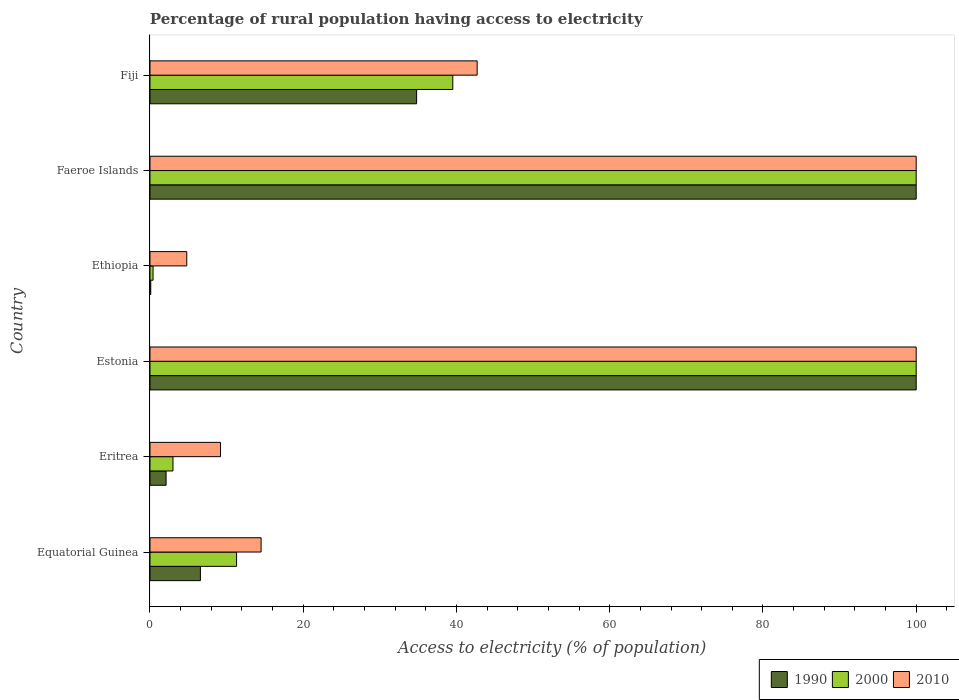How many groups of bars are there?
Make the answer very short. 6. Are the number of bars per tick equal to the number of legend labels?
Keep it short and to the point. Yes. How many bars are there on the 3rd tick from the bottom?
Your response must be concise. 3. What is the label of the 5th group of bars from the top?
Keep it short and to the point. Eritrea. In how many cases, is the number of bars for a given country not equal to the number of legend labels?
Your answer should be compact. 0. Across all countries, what is the maximum percentage of rural population having access to electricity in 2010?
Your answer should be compact. 100. Across all countries, what is the minimum percentage of rural population having access to electricity in 2000?
Provide a succinct answer. 0.4. In which country was the percentage of rural population having access to electricity in 2000 maximum?
Make the answer very short. Estonia. In which country was the percentage of rural population having access to electricity in 2000 minimum?
Offer a very short reply. Ethiopia. What is the total percentage of rural population having access to electricity in 1990 in the graph?
Offer a very short reply. 243.58. What is the difference between the percentage of rural population having access to electricity in 1990 in Faeroe Islands and the percentage of rural population having access to electricity in 2010 in Eritrea?
Your response must be concise. 90.8. What is the average percentage of rural population having access to electricity in 2000 per country?
Provide a succinct answer. 42.37. What is the difference between the percentage of rural population having access to electricity in 2000 and percentage of rural population having access to electricity in 2010 in Faeroe Islands?
Provide a short and direct response. 0. What is the ratio of the percentage of rural population having access to electricity in 2000 in Faeroe Islands to that in Fiji?
Offer a very short reply. 2.53. Is the percentage of rural population having access to electricity in 1990 in Equatorial Guinea less than that in Faeroe Islands?
Give a very brief answer. Yes. Is the difference between the percentage of rural population having access to electricity in 2000 in Ethiopia and Fiji greater than the difference between the percentage of rural population having access to electricity in 2010 in Ethiopia and Fiji?
Provide a succinct answer. No. What is the difference between the highest and the second highest percentage of rural population having access to electricity in 1990?
Ensure brevity in your answer.  0. What is the difference between the highest and the lowest percentage of rural population having access to electricity in 2010?
Offer a terse response. 95.2. Is the sum of the percentage of rural population having access to electricity in 2000 in Eritrea and Ethiopia greater than the maximum percentage of rural population having access to electricity in 2010 across all countries?
Offer a terse response. No. What does the 1st bar from the top in Faeroe Islands represents?
Your answer should be compact. 2010. What does the 3rd bar from the bottom in Fiji represents?
Give a very brief answer. 2010. Is it the case that in every country, the sum of the percentage of rural population having access to electricity in 2000 and percentage of rural population having access to electricity in 1990 is greater than the percentage of rural population having access to electricity in 2010?
Give a very brief answer. No. How many bars are there?
Offer a terse response. 18. Are all the bars in the graph horizontal?
Your answer should be compact. Yes. Does the graph contain any zero values?
Your answer should be compact. No. Does the graph contain grids?
Ensure brevity in your answer.  No. Where does the legend appear in the graph?
Make the answer very short. Bottom right. How are the legend labels stacked?
Provide a succinct answer. Horizontal. What is the title of the graph?
Offer a terse response. Percentage of rural population having access to electricity. What is the label or title of the X-axis?
Offer a terse response. Access to electricity (% of population). What is the label or title of the Y-axis?
Offer a very short reply. Country. What is the Access to electricity (% of population) in 1990 in Equatorial Guinea?
Keep it short and to the point. 6.58. What is the Access to electricity (% of population) of 2000 in Equatorial Guinea?
Give a very brief answer. 11.3. What is the Access to electricity (% of population) of 2010 in Equatorial Guinea?
Offer a very short reply. 14.5. What is the Access to electricity (% of population) in 2000 in Eritrea?
Your response must be concise. 3. What is the Access to electricity (% of population) in 1990 in Estonia?
Provide a succinct answer. 100. What is the Access to electricity (% of population) of 2010 in Estonia?
Your answer should be compact. 100. What is the Access to electricity (% of population) of 1990 in Ethiopia?
Ensure brevity in your answer.  0.1. What is the Access to electricity (% of population) in 2010 in Ethiopia?
Provide a short and direct response. 4.8. What is the Access to electricity (% of population) in 2000 in Faeroe Islands?
Your answer should be compact. 100. What is the Access to electricity (% of population) in 2010 in Faeroe Islands?
Keep it short and to the point. 100. What is the Access to electricity (% of population) of 1990 in Fiji?
Your answer should be very brief. 34.8. What is the Access to electricity (% of population) in 2000 in Fiji?
Give a very brief answer. 39.52. What is the Access to electricity (% of population) of 2010 in Fiji?
Keep it short and to the point. 42.7. Across all countries, what is the maximum Access to electricity (% of population) in 1990?
Give a very brief answer. 100. Across all countries, what is the maximum Access to electricity (% of population) in 2000?
Keep it short and to the point. 100. Across all countries, what is the maximum Access to electricity (% of population) in 2010?
Offer a terse response. 100. What is the total Access to electricity (% of population) in 1990 in the graph?
Give a very brief answer. 243.58. What is the total Access to electricity (% of population) of 2000 in the graph?
Provide a succinct answer. 254.22. What is the total Access to electricity (% of population) in 2010 in the graph?
Give a very brief answer. 271.2. What is the difference between the Access to electricity (% of population) in 1990 in Equatorial Guinea and that in Eritrea?
Provide a short and direct response. 4.48. What is the difference between the Access to electricity (% of population) in 2000 in Equatorial Guinea and that in Eritrea?
Your answer should be compact. 8.3. What is the difference between the Access to electricity (% of population) of 1990 in Equatorial Guinea and that in Estonia?
Offer a very short reply. -93.42. What is the difference between the Access to electricity (% of population) in 2000 in Equatorial Guinea and that in Estonia?
Provide a succinct answer. -88.7. What is the difference between the Access to electricity (% of population) of 2010 in Equatorial Guinea and that in Estonia?
Make the answer very short. -85.5. What is the difference between the Access to electricity (% of population) in 1990 in Equatorial Guinea and that in Ethiopia?
Keep it short and to the point. 6.48. What is the difference between the Access to electricity (% of population) of 2000 in Equatorial Guinea and that in Ethiopia?
Ensure brevity in your answer.  10.9. What is the difference between the Access to electricity (% of population) of 1990 in Equatorial Guinea and that in Faeroe Islands?
Offer a very short reply. -93.42. What is the difference between the Access to electricity (% of population) of 2000 in Equatorial Guinea and that in Faeroe Islands?
Your response must be concise. -88.7. What is the difference between the Access to electricity (% of population) of 2010 in Equatorial Guinea and that in Faeroe Islands?
Your answer should be compact. -85.5. What is the difference between the Access to electricity (% of population) in 1990 in Equatorial Guinea and that in Fiji?
Ensure brevity in your answer.  -28.22. What is the difference between the Access to electricity (% of population) in 2000 in Equatorial Guinea and that in Fiji?
Ensure brevity in your answer.  -28.22. What is the difference between the Access to electricity (% of population) of 2010 in Equatorial Guinea and that in Fiji?
Ensure brevity in your answer.  -28.2. What is the difference between the Access to electricity (% of population) of 1990 in Eritrea and that in Estonia?
Offer a very short reply. -97.9. What is the difference between the Access to electricity (% of population) of 2000 in Eritrea and that in Estonia?
Ensure brevity in your answer.  -97. What is the difference between the Access to electricity (% of population) of 2010 in Eritrea and that in Estonia?
Your answer should be compact. -90.8. What is the difference between the Access to electricity (% of population) of 2000 in Eritrea and that in Ethiopia?
Offer a very short reply. 2.6. What is the difference between the Access to electricity (% of population) of 1990 in Eritrea and that in Faeroe Islands?
Keep it short and to the point. -97.9. What is the difference between the Access to electricity (% of population) in 2000 in Eritrea and that in Faeroe Islands?
Provide a short and direct response. -97. What is the difference between the Access to electricity (% of population) of 2010 in Eritrea and that in Faeroe Islands?
Your response must be concise. -90.8. What is the difference between the Access to electricity (% of population) of 1990 in Eritrea and that in Fiji?
Offer a terse response. -32.7. What is the difference between the Access to electricity (% of population) in 2000 in Eritrea and that in Fiji?
Your response must be concise. -36.52. What is the difference between the Access to electricity (% of population) in 2010 in Eritrea and that in Fiji?
Ensure brevity in your answer.  -33.5. What is the difference between the Access to electricity (% of population) of 1990 in Estonia and that in Ethiopia?
Make the answer very short. 99.9. What is the difference between the Access to electricity (% of population) in 2000 in Estonia and that in Ethiopia?
Your answer should be compact. 99.6. What is the difference between the Access to electricity (% of population) of 2010 in Estonia and that in Ethiopia?
Your response must be concise. 95.2. What is the difference between the Access to electricity (% of population) in 2000 in Estonia and that in Faeroe Islands?
Provide a short and direct response. 0. What is the difference between the Access to electricity (% of population) of 2010 in Estonia and that in Faeroe Islands?
Keep it short and to the point. 0. What is the difference between the Access to electricity (% of population) in 1990 in Estonia and that in Fiji?
Ensure brevity in your answer.  65.2. What is the difference between the Access to electricity (% of population) in 2000 in Estonia and that in Fiji?
Your answer should be compact. 60.48. What is the difference between the Access to electricity (% of population) in 2010 in Estonia and that in Fiji?
Make the answer very short. 57.3. What is the difference between the Access to electricity (% of population) in 1990 in Ethiopia and that in Faeroe Islands?
Give a very brief answer. -99.9. What is the difference between the Access to electricity (% of population) of 2000 in Ethiopia and that in Faeroe Islands?
Your answer should be compact. -99.6. What is the difference between the Access to electricity (% of population) in 2010 in Ethiopia and that in Faeroe Islands?
Provide a succinct answer. -95.2. What is the difference between the Access to electricity (% of population) of 1990 in Ethiopia and that in Fiji?
Your response must be concise. -34.7. What is the difference between the Access to electricity (% of population) of 2000 in Ethiopia and that in Fiji?
Your answer should be very brief. -39.12. What is the difference between the Access to electricity (% of population) of 2010 in Ethiopia and that in Fiji?
Give a very brief answer. -37.9. What is the difference between the Access to electricity (% of population) of 1990 in Faeroe Islands and that in Fiji?
Your answer should be very brief. 65.2. What is the difference between the Access to electricity (% of population) of 2000 in Faeroe Islands and that in Fiji?
Provide a succinct answer. 60.48. What is the difference between the Access to electricity (% of population) in 2010 in Faeroe Islands and that in Fiji?
Provide a short and direct response. 57.3. What is the difference between the Access to electricity (% of population) in 1990 in Equatorial Guinea and the Access to electricity (% of population) in 2000 in Eritrea?
Your answer should be very brief. 3.58. What is the difference between the Access to electricity (% of population) in 1990 in Equatorial Guinea and the Access to electricity (% of population) in 2010 in Eritrea?
Provide a succinct answer. -2.62. What is the difference between the Access to electricity (% of population) of 2000 in Equatorial Guinea and the Access to electricity (% of population) of 2010 in Eritrea?
Offer a very short reply. 2.1. What is the difference between the Access to electricity (% of population) of 1990 in Equatorial Guinea and the Access to electricity (% of population) of 2000 in Estonia?
Your answer should be compact. -93.42. What is the difference between the Access to electricity (% of population) of 1990 in Equatorial Guinea and the Access to electricity (% of population) of 2010 in Estonia?
Make the answer very short. -93.42. What is the difference between the Access to electricity (% of population) of 2000 in Equatorial Guinea and the Access to electricity (% of population) of 2010 in Estonia?
Give a very brief answer. -88.7. What is the difference between the Access to electricity (% of population) of 1990 in Equatorial Guinea and the Access to electricity (% of population) of 2000 in Ethiopia?
Provide a short and direct response. 6.18. What is the difference between the Access to electricity (% of population) of 1990 in Equatorial Guinea and the Access to electricity (% of population) of 2010 in Ethiopia?
Your answer should be compact. 1.78. What is the difference between the Access to electricity (% of population) of 2000 in Equatorial Guinea and the Access to electricity (% of population) of 2010 in Ethiopia?
Make the answer very short. 6.5. What is the difference between the Access to electricity (% of population) of 1990 in Equatorial Guinea and the Access to electricity (% of population) of 2000 in Faeroe Islands?
Offer a terse response. -93.42. What is the difference between the Access to electricity (% of population) of 1990 in Equatorial Guinea and the Access to electricity (% of population) of 2010 in Faeroe Islands?
Offer a very short reply. -93.42. What is the difference between the Access to electricity (% of population) in 2000 in Equatorial Guinea and the Access to electricity (% of population) in 2010 in Faeroe Islands?
Keep it short and to the point. -88.7. What is the difference between the Access to electricity (% of population) of 1990 in Equatorial Guinea and the Access to electricity (% of population) of 2000 in Fiji?
Give a very brief answer. -32.94. What is the difference between the Access to electricity (% of population) of 1990 in Equatorial Guinea and the Access to electricity (% of population) of 2010 in Fiji?
Your answer should be compact. -36.12. What is the difference between the Access to electricity (% of population) in 2000 in Equatorial Guinea and the Access to electricity (% of population) in 2010 in Fiji?
Your answer should be compact. -31.4. What is the difference between the Access to electricity (% of population) in 1990 in Eritrea and the Access to electricity (% of population) in 2000 in Estonia?
Your answer should be very brief. -97.9. What is the difference between the Access to electricity (% of population) in 1990 in Eritrea and the Access to electricity (% of population) in 2010 in Estonia?
Offer a very short reply. -97.9. What is the difference between the Access to electricity (% of population) in 2000 in Eritrea and the Access to electricity (% of population) in 2010 in Estonia?
Provide a short and direct response. -97. What is the difference between the Access to electricity (% of population) of 1990 in Eritrea and the Access to electricity (% of population) of 2010 in Ethiopia?
Your answer should be compact. -2.7. What is the difference between the Access to electricity (% of population) of 1990 in Eritrea and the Access to electricity (% of population) of 2000 in Faeroe Islands?
Offer a very short reply. -97.9. What is the difference between the Access to electricity (% of population) in 1990 in Eritrea and the Access to electricity (% of population) in 2010 in Faeroe Islands?
Give a very brief answer. -97.9. What is the difference between the Access to electricity (% of population) in 2000 in Eritrea and the Access to electricity (% of population) in 2010 in Faeroe Islands?
Offer a very short reply. -97. What is the difference between the Access to electricity (% of population) in 1990 in Eritrea and the Access to electricity (% of population) in 2000 in Fiji?
Give a very brief answer. -37.42. What is the difference between the Access to electricity (% of population) of 1990 in Eritrea and the Access to electricity (% of population) of 2010 in Fiji?
Your answer should be very brief. -40.6. What is the difference between the Access to electricity (% of population) of 2000 in Eritrea and the Access to electricity (% of population) of 2010 in Fiji?
Your answer should be very brief. -39.7. What is the difference between the Access to electricity (% of population) of 1990 in Estonia and the Access to electricity (% of population) of 2000 in Ethiopia?
Keep it short and to the point. 99.6. What is the difference between the Access to electricity (% of population) of 1990 in Estonia and the Access to electricity (% of population) of 2010 in Ethiopia?
Provide a succinct answer. 95.2. What is the difference between the Access to electricity (% of population) of 2000 in Estonia and the Access to electricity (% of population) of 2010 in Ethiopia?
Offer a terse response. 95.2. What is the difference between the Access to electricity (% of population) in 1990 in Estonia and the Access to electricity (% of population) in 2000 in Faeroe Islands?
Your answer should be very brief. 0. What is the difference between the Access to electricity (% of population) in 1990 in Estonia and the Access to electricity (% of population) in 2010 in Faeroe Islands?
Provide a short and direct response. 0. What is the difference between the Access to electricity (% of population) of 1990 in Estonia and the Access to electricity (% of population) of 2000 in Fiji?
Your answer should be compact. 60.48. What is the difference between the Access to electricity (% of population) in 1990 in Estonia and the Access to electricity (% of population) in 2010 in Fiji?
Your answer should be very brief. 57.3. What is the difference between the Access to electricity (% of population) in 2000 in Estonia and the Access to electricity (% of population) in 2010 in Fiji?
Your response must be concise. 57.3. What is the difference between the Access to electricity (% of population) of 1990 in Ethiopia and the Access to electricity (% of population) of 2000 in Faeroe Islands?
Ensure brevity in your answer.  -99.9. What is the difference between the Access to electricity (% of population) in 1990 in Ethiopia and the Access to electricity (% of population) in 2010 in Faeroe Islands?
Provide a short and direct response. -99.9. What is the difference between the Access to electricity (% of population) in 2000 in Ethiopia and the Access to electricity (% of population) in 2010 in Faeroe Islands?
Keep it short and to the point. -99.6. What is the difference between the Access to electricity (% of population) in 1990 in Ethiopia and the Access to electricity (% of population) in 2000 in Fiji?
Offer a terse response. -39.42. What is the difference between the Access to electricity (% of population) of 1990 in Ethiopia and the Access to electricity (% of population) of 2010 in Fiji?
Your answer should be compact. -42.6. What is the difference between the Access to electricity (% of population) in 2000 in Ethiopia and the Access to electricity (% of population) in 2010 in Fiji?
Keep it short and to the point. -42.3. What is the difference between the Access to electricity (% of population) in 1990 in Faeroe Islands and the Access to electricity (% of population) in 2000 in Fiji?
Provide a succinct answer. 60.48. What is the difference between the Access to electricity (% of population) in 1990 in Faeroe Islands and the Access to electricity (% of population) in 2010 in Fiji?
Your response must be concise. 57.3. What is the difference between the Access to electricity (% of population) of 2000 in Faeroe Islands and the Access to electricity (% of population) of 2010 in Fiji?
Make the answer very short. 57.3. What is the average Access to electricity (% of population) of 1990 per country?
Give a very brief answer. 40.6. What is the average Access to electricity (% of population) in 2000 per country?
Offer a terse response. 42.37. What is the average Access to electricity (% of population) in 2010 per country?
Provide a short and direct response. 45.2. What is the difference between the Access to electricity (% of population) of 1990 and Access to electricity (% of population) of 2000 in Equatorial Guinea?
Keep it short and to the point. -4.72. What is the difference between the Access to electricity (% of population) in 1990 and Access to electricity (% of population) in 2010 in Equatorial Guinea?
Your response must be concise. -7.92. What is the difference between the Access to electricity (% of population) in 2000 and Access to electricity (% of population) in 2010 in Equatorial Guinea?
Make the answer very short. -3.2. What is the difference between the Access to electricity (% of population) in 1990 and Access to electricity (% of population) in 2010 in Eritrea?
Provide a succinct answer. -7.1. What is the difference between the Access to electricity (% of population) in 1990 and Access to electricity (% of population) in 2000 in Estonia?
Your answer should be compact. 0. What is the difference between the Access to electricity (% of population) in 1990 and Access to electricity (% of population) in 2010 in Estonia?
Provide a short and direct response. 0. What is the difference between the Access to electricity (% of population) in 2000 and Access to electricity (% of population) in 2010 in Estonia?
Your response must be concise. 0. What is the difference between the Access to electricity (% of population) in 1990 and Access to electricity (% of population) in 2010 in Ethiopia?
Keep it short and to the point. -4.7. What is the difference between the Access to electricity (% of population) in 2000 and Access to electricity (% of population) in 2010 in Ethiopia?
Your answer should be compact. -4.4. What is the difference between the Access to electricity (% of population) of 1990 and Access to electricity (% of population) of 2000 in Faeroe Islands?
Provide a succinct answer. 0. What is the difference between the Access to electricity (% of population) of 2000 and Access to electricity (% of population) of 2010 in Faeroe Islands?
Make the answer very short. 0. What is the difference between the Access to electricity (% of population) of 1990 and Access to electricity (% of population) of 2000 in Fiji?
Provide a short and direct response. -4.72. What is the difference between the Access to electricity (% of population) in 1990 and Access to electricity (% of population) in 2010 in Fiji?
Keep it short and to the point. -7.9. What is the difference between the Access to electricity (% of population) of 2000 and Access to electricity (% of population) of 2010 in Fiji?
Offer a very short reply. -3.18. What is the ratio of the Access to electricity (% of population) in 1990 in Equatorial Guinea to that in Eritrea?
Provide a short and direct response. 3.13. What is the ratio of the Access to electricity (% of population) in 2000 in Equatorial Guinea to that in Eritrea?
Your answer should be compact. 3.77. What is the ratio of the Access to electricity (% of population) of 2010 in Equatorial Guinea to that in Eritrea?
Offer a very short reply. 1.58. What is the ratio of the Access to electricity (% of population) of 1990 in Equatorial Guinea to that in Estonia?
Offer a terse response. 0.07. What is the ratio of the Access to electricity (% of population) in 2000 in Equatorial Guinea to that in Estonia?
Give a very brief answer. 0.11. What is the ratio of the Access to electricity (% of population) of 2010 in Equatorial Guinea to that in Estonia?
Your answer should be very brief. 0.14. What is the ratio of the Access to electricity (% of population) in 1990 in Equatorial Guinea to that in Ethiopia?
Offer a very short reply. 65.79. What is the ratio of the Access to electricity (% of population) in 2000 in Equatorial Guinea to that in Ethiopia?
Provide a succinct answer. 28.25. What is the ratio of the Access to electricity (% of population) in 2010 in Equatorial Guinea to that in Ethiopia?
Your answer should be very brief. 3.02. What is the ratio of the Access to electricity (% of population) in 1990 in Equatorial Guinea to that in Faeroe Islands?
Give a very brief answer. 0.07. What is the ratio of the Access to electricity (% of population) in 2000 in Equatorial Guinea to that in Faeroe Islands?
Provide a short and direct response. 0.11. What is the ratio of the Access to electricity (% of population) of 2010 in Equatorial Guinea to that in Faeroe Islands?
Your response must be concise. 0.14. What is the ratio of the Access to electricity (% of population) of 1990 in Equatorial Guinea to that in Fiji?
Ensure brevity in your answer.  0.19. What is the ratio of the Access to electricity (% of population) in 2000 in Equatorial Guinea to that in Fiji?
Offer a very short reply. 0.29. What is the ratio of the Access to electricity (% of population) in 2010 in Equatorial Guinea to that in Fiji?
Offer a terse response. 0.34. What is the ratio of the Access to electricity (% of population) of 1990 in Eritrea to that in Estonia?
Your answer should be compact. 0.02. What is the ratio of the Access to electricity (% of population) in 2000 in Eritrea to that in Estonia?
Your answer should be very brief. 0.03. What is the ratio of the Access to electricity (% of population) of 2010 in Eritrea to that in Estonia?
Offer a terse response. 0.09. What is the ratio of the Access to electricity (% of population) in 2010 in Eritrea to that in Ethiopia?
Your answer should be compact. 1.92. What is the ratio of the Access to electricity (% of population) of 1990 in Eritrea to that in Faeroe Islands?
Your answer should be compact. 0.02. What is the ratio of the Access to electricity (% of population) of 2000 in Eritrea to that in Faeroe Islands?
Offer a terse response. 0.03. What is the ratio of the Access to electricity (% of population) in 2010 in Eritrea to that in Faeroe Islands?
Offer a very short reply. 0.09. What is the ratio of the Access to electricity (% of population) of 1990 in Eritrea to that in Fiji?
Give a very brief answer. 0.06. What is the ratio of the Access to electricity (% of population) of 2000 in Eritrea to that in Fiji?
Keep it short and to the point. 0.08. What is the ratio of the Access to electricity (% of population) in 2010 in Eritrea to that in Fiji?
Your answer should be very brief. 0.22. What is the ratio of the Access to electricity (% of population) of 1990 in Estonia to that in Ethiopia?
Provide a succinct answer. 1000. What is the ratio of the Access to electricity (% of population) in 2000 in Estonia to that in Ethiopia?
Offer a terse response. 250. What is the ratio of the Access to electricity (% of population) in 2010 in Estonia to that in Ethiopia?
Give a very brief answer. 20.83. What is the ratio of the Access to electricity (% of population) in 1990 in Estonia to that in Faeroe Islands?
Ensure brevity in your answer.  1. What is the ratio of the Access to electricity (% of population) of 2000 in Estonia to that in Faeroe Islands?
Your response must be concise. 1. What is the ratio of the Access to electricity (% of population) of 1990 in Estonia to that in Fiji?
Make the answer very short. 2.87. What is the ratio of the Access to electricity (% of population) of 2000 in Estonia to that in Fiji?
Offer a very short reply. 2.53. What is the ratio of the Access to electricity (% of population) in 2010 in Estonia to that in Fiji?
Provide a short and direct response. 2.34. What is the ratio of the Access to electricity (% of population) in 2000 in Ethiopia to that in Faeroe Islands?
Offer a very short reply. 0. What is the ratio of the Access to electricity (% of population) of 2010 in Ethiopia to that in Faeroe Islands?
Keep it short and to the point. 0.05. What is the ratio of the Access to electricity (% of population) of 1990 in Ethiopia to that in Fiji?
Provide a succinct answer. 0. What is the ratio of the Access to electricity (% of population) of 2000 in Ethiopia to that in Fiji?
Your answer should be compact. 0.01. What is the ratio of the Access to electricity (% of population) of 2010 in Ethiopia to that in Fiji?
Give a very brief answer. 0.11. What is the ratio of the Access to electricity (% of population) in 1990 in Faeroe Islands to that in Fiji?
Your response must be concise. 2.87. What is the ratio of the Access to electricity (% of population) of 2000 in Faeroe Islands to that in Fiji?
Provide a succinct answer. 2.53. What is the ratio of the Access to electricity (% of population) in 2010 in Faeroe Islands to that in Fiji?
Provide a short and direct response. 2.34. What is the difference between the highest and the second highest Access to electricity (% of population) of 1990?
Keep it short and to the point. 0. What is the difference between the highest and the lowest Access to electricity (% of population) of 1990?
Ensure brevity in your answer.  99.9. What is the difference between the highest and the lowest Access to electricity (% of population) in 2000?
Your answer should be very brief. 99.6. What is the difference between the highest and the lowest Access to electricity (% of population) of 2010?
Your answer should be compact. 95.2. 